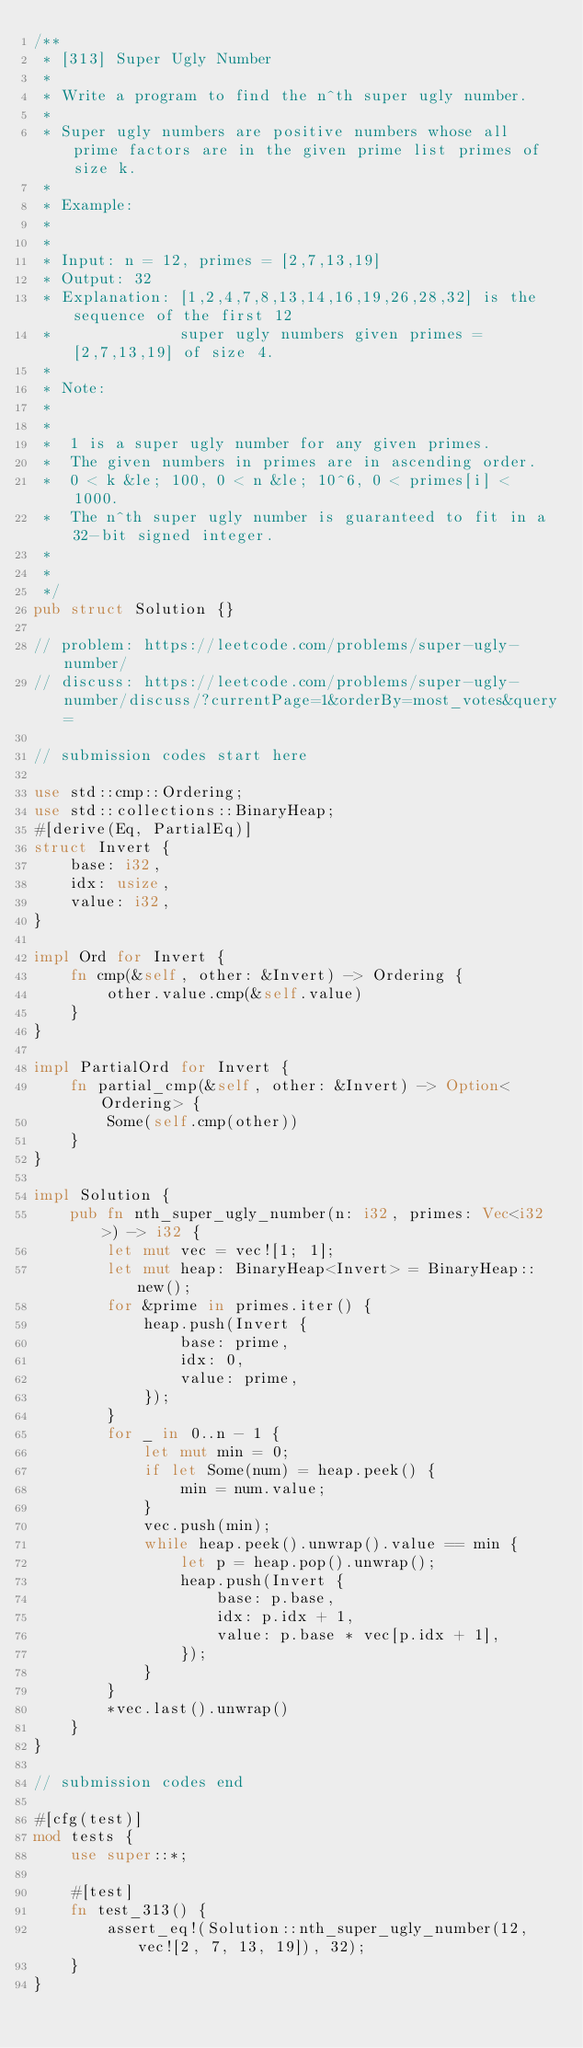Convert code to text. <code><loc_0><loc_0><loc_500><loc_500><_Rust_>/**
 * [313] Super Ugly Number
 *
 * Write a program to find the n^th super ugly number.
 *
 * Super ugly numbers are positive numbers whose all prime factors are in the given prime list primes of size k.
 *
 * Example:
 *
 *
 * Input: n = 12, primes = [2,7,13,19]
 * Output: 32
 * Explanation: [1,2,4,7,8,13,14,16,19,26,28,32] is the sequence of the first 12
 *              super ugly numbers given primes = [2,7,13,19] of size 4.
 *
 * Note:
 *
 *
 * 	1 is a super ugly number for any given primes.
 * 	The given numbers in primes are in ascending order.
 * 	0 < k &le; 100, 0 < n &le; 10^6, 0 < primes[i] < 1000.
 * 	The n^th super ugly number is guaranteed to fit in a 32-bit signed integer.
 *
 *
 */
pub struct Solution {}

// problem: https://leetcode.com/problems/super-ugly-number/
// discuss: https://leetcode.com/problems/super-ugly-number/discuss/?currentPage=1&orderBy=most_votes&query=

// submission codes start here

use std::cmp::Ordering;
use std::collections::BinaryHeap;
#[derive(Eq, PartialEq)]
struct Invert {
    base: i32,
    idx: usize,
    value: i32,
}

impl Ord for Invert {
    fn cmp(&self, other: &Invert) -> Ordering {
        other.value.cmp(&self.value)
    }
}

impl PartialOrd for Invert {
    fn partial_cmp(&self, other: &Invert) -> Option<Ordering> {
        Some(self.cmp(other))
    }
}

impl Solution {
    pub fn nth_super_ugly_number(n: i32, primes: Vec<i32>) -> i32 {
        let mut vec = vec![1; 1];
        let mut heap: BinaryHeap<Invert> = BinaryHeap::new();
        for &prime in primes.iter() {
            heap.push(Invert {
                base: prime,
                idx: 0,
                value: prime,
            });
        }
        for _ in 0..n - 1 {
            let mut min = 0;
            if let Some(num) = heap.peek() {
                min = num.value;
            }
            vec.push(min);
            while heap.peek().unwrap().value == min {
                let p = heap.pop().unwrap();
                heap.push(Invert {
                    base: p.base,
                    idx: p.idx + 1,
                    value: p.base * vec[p.idx + 1],
                });
            }
        }
        *vec.last().unwrap()
    }
}

// submission codes end

#[cfg(test)]
mod tests {
    use super::*;

    #[test]
    fn test_313() {
        assert_eq!(Solution::nth_super_ugly_number(12, vec![2, 7, 13, 19]), 32);
    }
}
</code> 